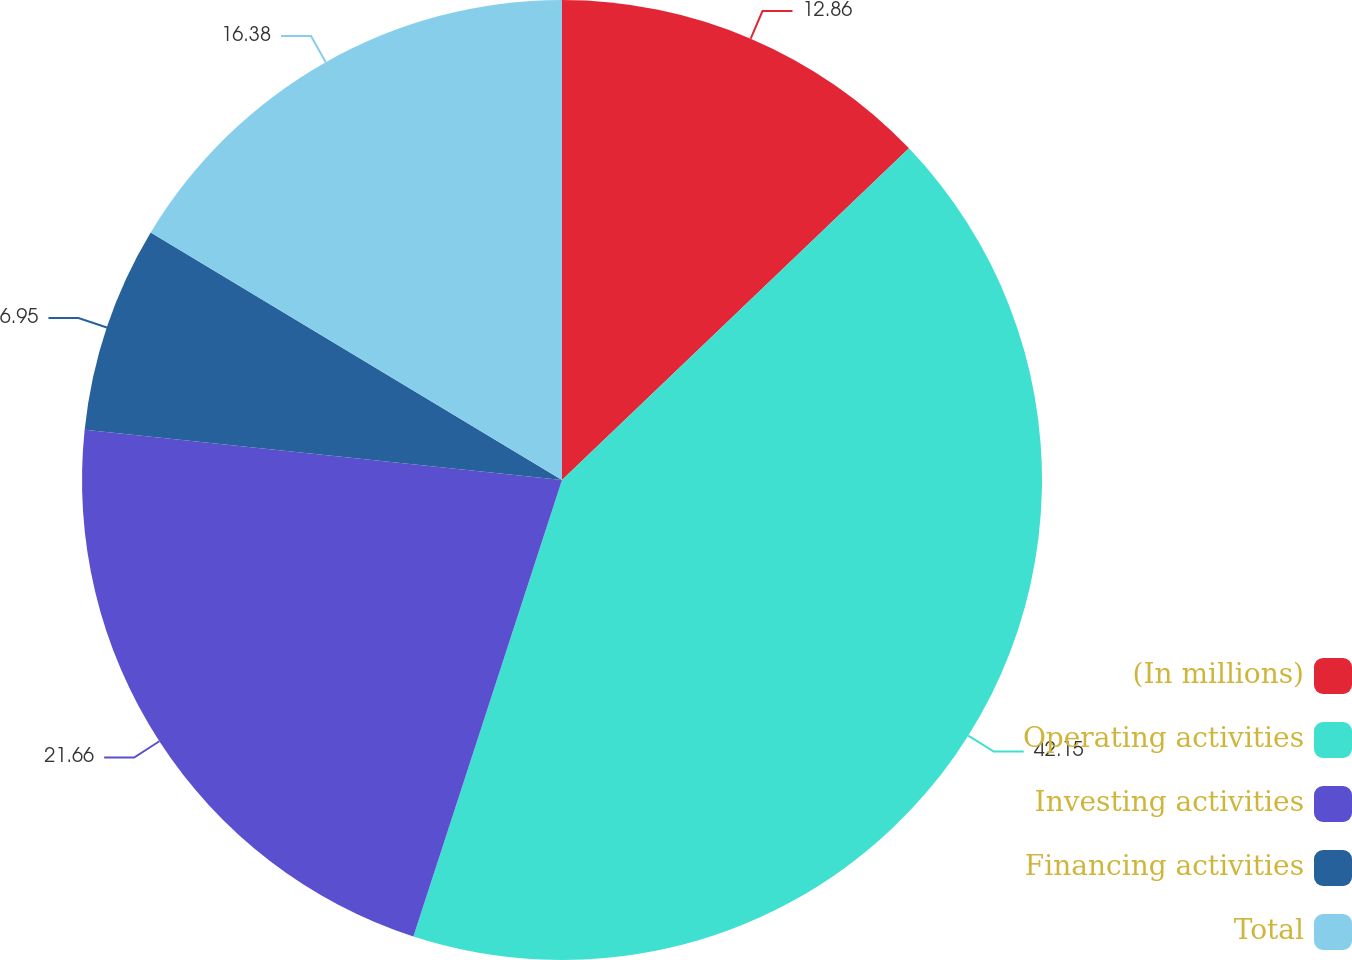Convert chart. <chart><loc_0><loc_0><loc_500><loc_500><pie_chart><fcel>(In millions)<fcel>Operating activities<fcel>Investing activities<fcel>Financing activities<fcel>Total<nl><fcel>12.86%<fcel>42.15%<fcel>21.66%<fcel>6.95%<fcel>16.38%<nl></chart> 